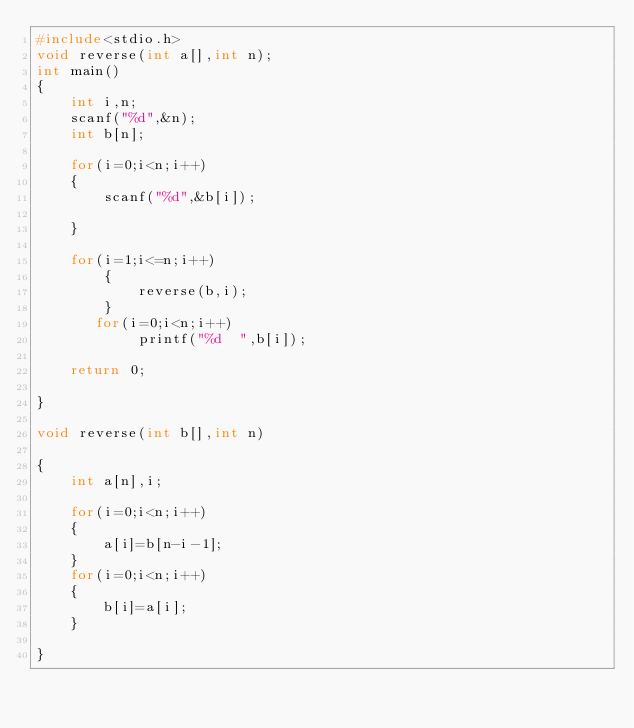Convert code to text. <code><loc_0><loc_0><loc_500><loc_500><_C_>#include<stdio.h>
void reverse(int a[],int n);
int main()
{
    int i,n;
    scanf("%d",&n);
    int b[n];

    for(i=0;i<n;i++)
    {
        scanf("%d",&b[i]);

    }

    for(i=1;i<=n;i++)
        {
            reverse(b,i);
        }
       for(i=0;i<n;i++)
            printf("%d  ",b[i]);

    return 0;

}

void reverse(int b[],int n)

{
    int a[n],i;

    for(i=0;i<n;i++)
    {
        a[i]=b[n-i-1];
    }
    for(i=0;i<n;i++)
    {
        b[i]=a[i];
    }

}</code> 